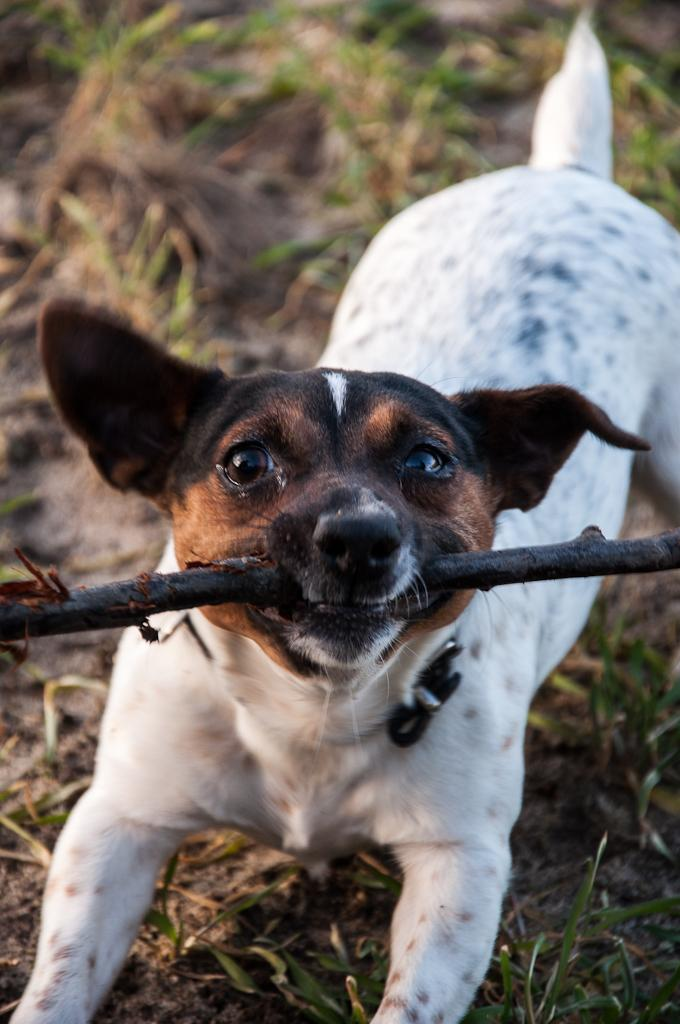What animal can be seen in the image? There is a dog in the image. What is the dog holding in its mouth? The dog is holding a wooden stem in its mouth. Can you describe the background of the image? The background of the image is blurred. What type of popcorn is being served in the image? There is no popcorn present in the image. What direction is the dog facing in the image? The dog's direction is not mentioned in the provided facts, so it cannot be determined from the image. 